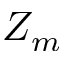<formula> <loc_0><loc_0><loc_500><loc_500>Z _ { m }</formula> 